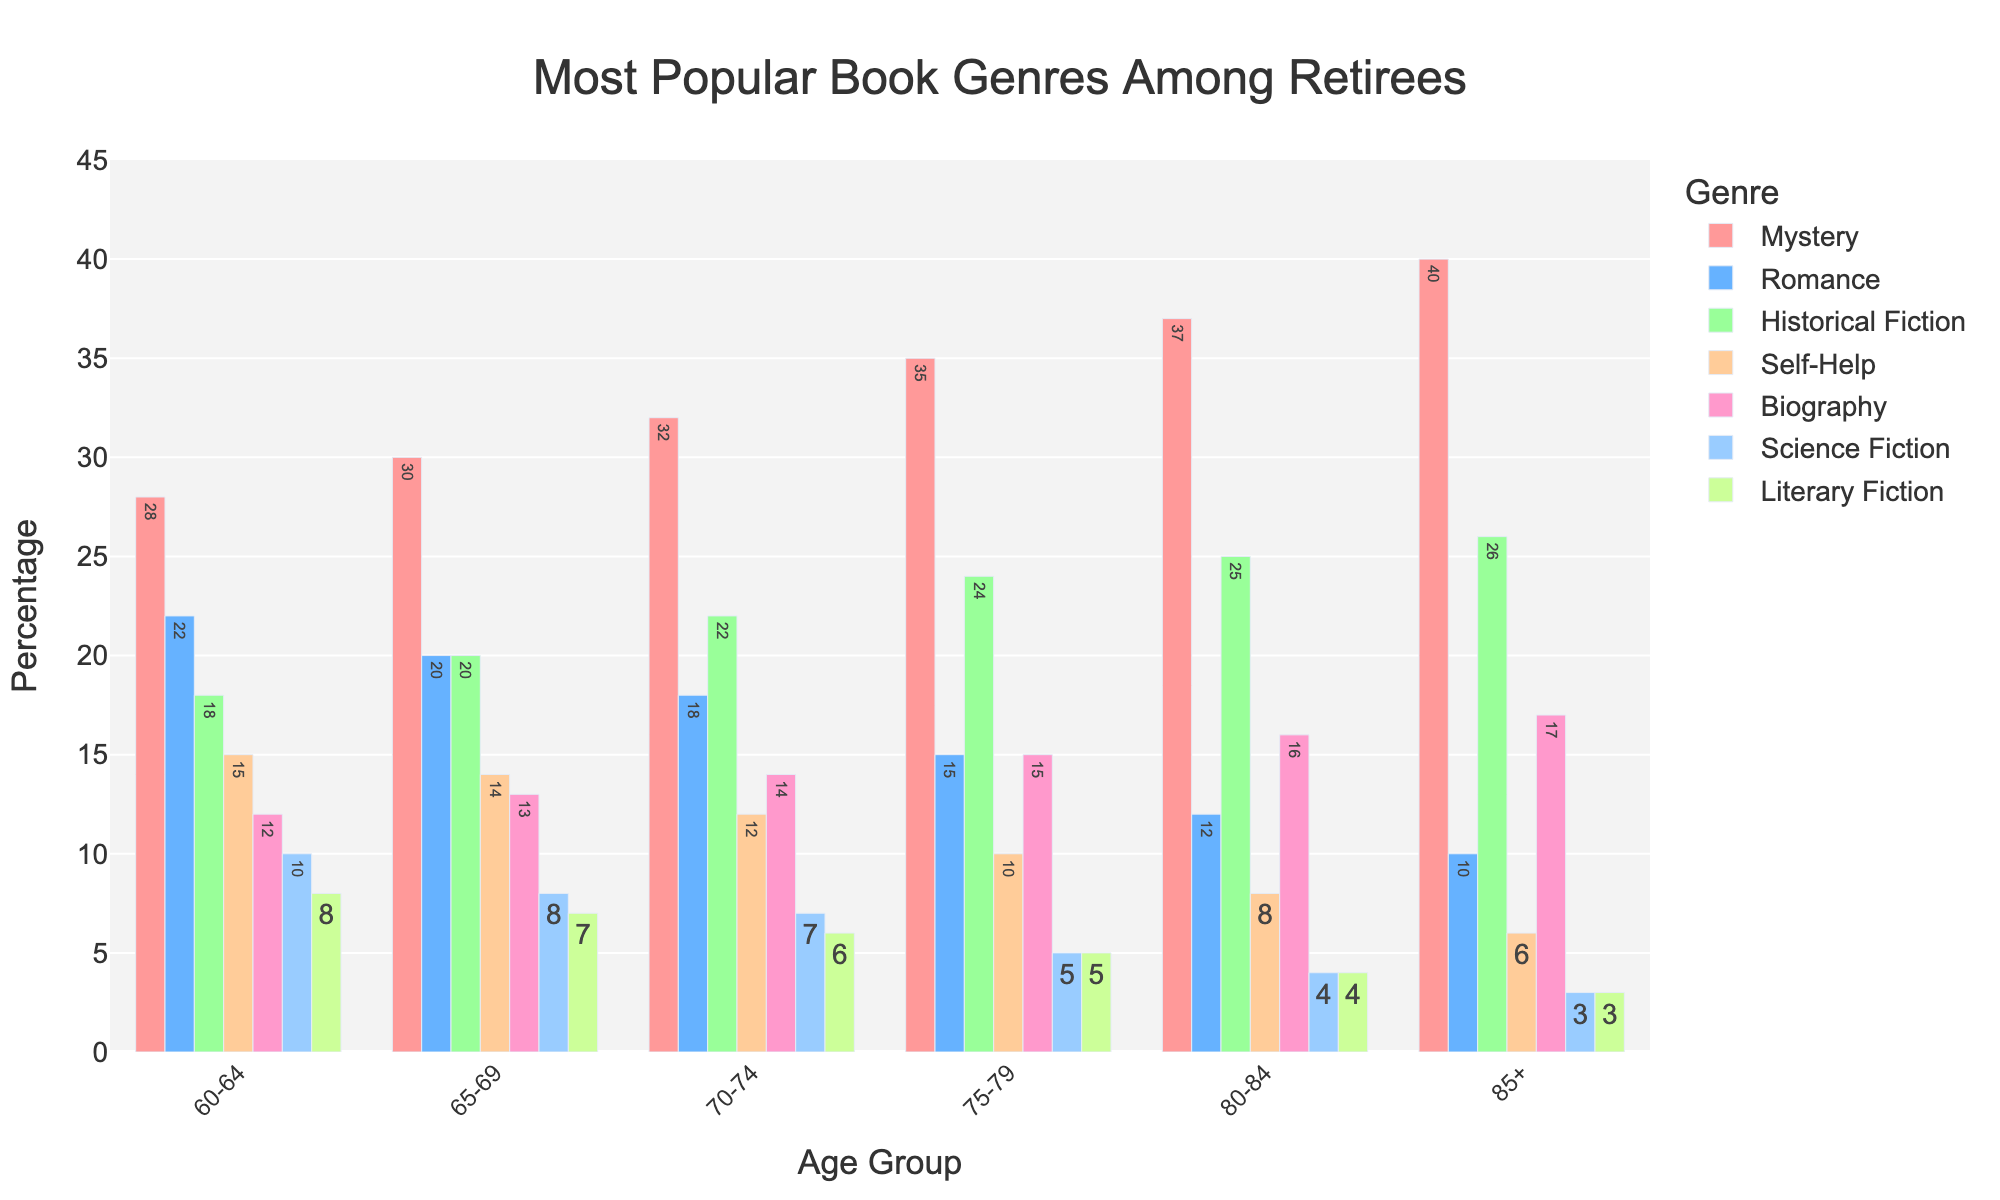What is the most popular book genre for retirees aged 60-64? The highest bar for the age group 60-64 is Mystery. Observing the figure, Mystery has the tallest bar when compared to other genres.
Answer: Mystery How does the popularity of Romance change as the age group increases? For Romance, observe the bars across all age groups. The height of the bars decreases as the age groups move from 60-64 to 85+. It starts at 22 for 60-64 and falls to 10 for 85+.
Answer: Decreases Which age group shows the highest interest in Self-Help books? The bar for Self-Help is highest for the age group 60-64 when compared across all age groups.
Answer: 60-64 Compare the popularity of Biography and Science Fiction for the age group 75-79. The bar for Biography in the 75-79 age group reaches up to 15, while the bar for Science Fiction reaches up to 5, indicating Biography is higher in popularity than Science Fiction for this age group.
Answer: Biography is more popular In which age group is there the largest gap between the popularity of Mystery and Literary Fiction? Examine the difference between the bars for Mystery and Literary Fiction across all age groups. The largest gap occurs in the age group 85+, where Mystery reaches 40 and Literary Fiction is at 3, making a gap of 37.
Answer: 85+ What is the average popularity of Historical Fiction for the age groups 60-64 and 65-69? The popularity of Historical Fiction for 60-64 is 18, and for 65-69 is 20. Calculate the average: (18 + 20) / 2 = 19.
Answer: 19 Summing the popularity percentages of Mystery and Historical Fiction, which age group has the highest total? For each age group, add the values of Mystery and Historical Fiction:
- 60-64: 28 + 18 = 46
- 65-69: 30 + 20 = 50
- 70-74: 32 + 22 = 54
- 75-79: 35 + 24 = 59
- 80-84: 37 + 25 = 62
- 85+: 40 + 26 = 66
The highest total is for the age group 85+, which is 66.
Answer: 85+ By how much does the popularity of Science Fiction decrease from the age group 60-64 to 85+? The popularity of Science Fiction at 60-64 is 10 and at 85+ is 3. The decrease is 10 - 3 = 7.
Answer: 7 What is the overall trend in the popularity of Literary Fiction across all age groups? Observe the bars for Literary Fiction from age group 60-64 to 85+. The trend shows a consistent decrease: from 8 for age 60-64 to 3 for 85+.
Answer: Decreases Which genre has the best consistent increase in popularity as age increases? By examining each genre bar across the age groups, Mystery shows an increase in its values from 28 in 60-64 to 40 in 85+, indicating consistent growth.
Answer: Mystery 